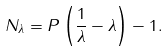Convert formula to latex. <formula><loc_0><loc_0><loc_500><loc_500>N _ { \lambda } = P \left ( \frac { 1 } { \lambda } - \lambda \right ) - 1 .</formula> 